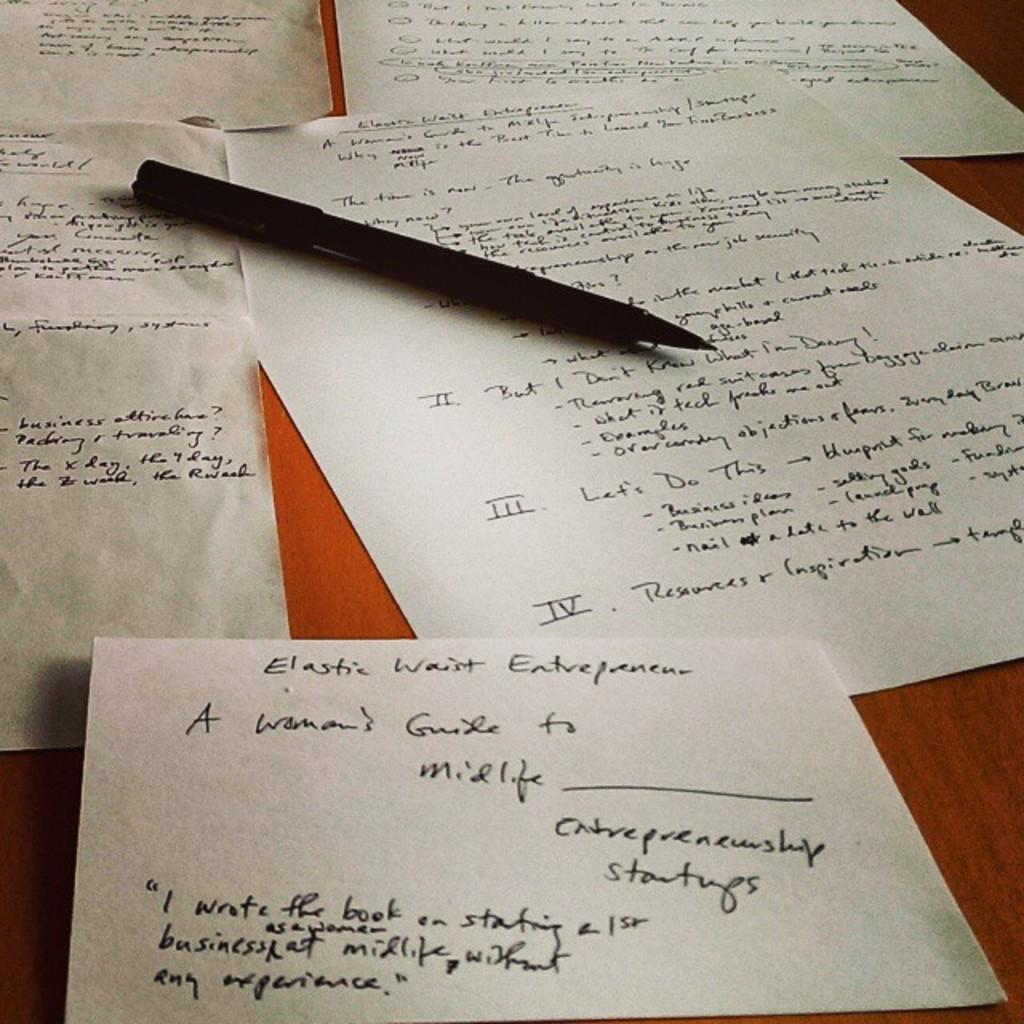What type of writing material can be seen in the image? There is a pen in the image. What is placed on the wooden surface in the background of the image? There are text papers in the image. Can you describe the surface on which the text papers are placed? The wooden surface is in the background of the image. What type of feather can be seen connected to the pen in the image? There is no feather connected to the pen in the image. How does the toad interact with the text papers in the image? There is no toad present in the image. 